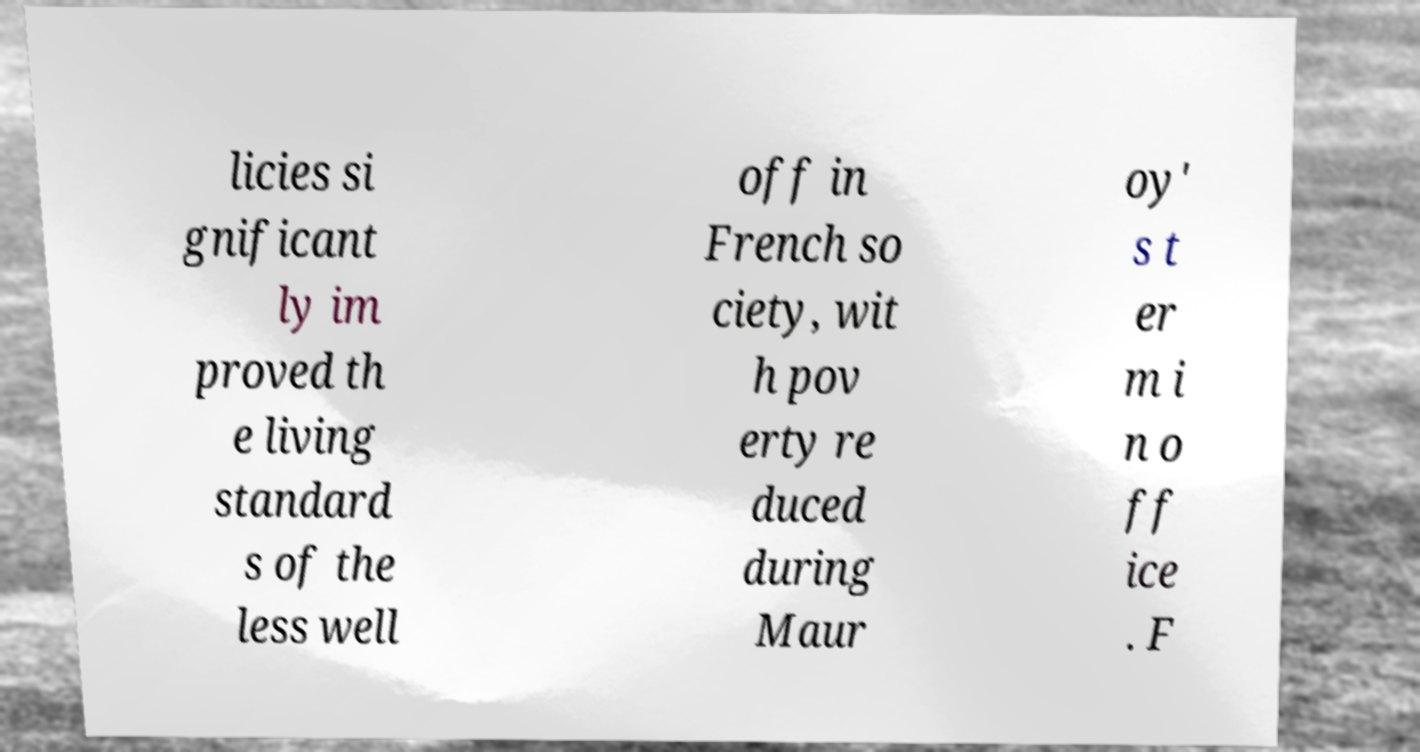Could you assist in decoding the text presented in this image and type it out clearly? licies si gnificant ly im proved th e living standard s of the less well off in French so ciety, wit h pov erty re duced during Maur oy' s t er m i n o ff ice . F 